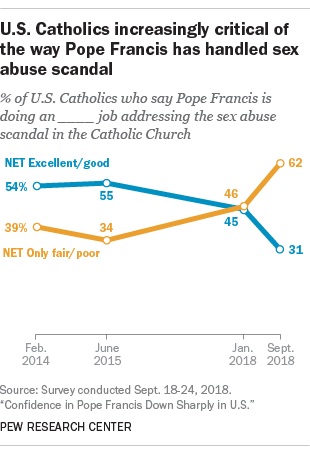Outline some significant characteristics in this image. The blue graph represents a positive evaluation, indicating that the entity being evaluated is excellent or good. The product of the smallest values of the orange graph is greater than 1000. 